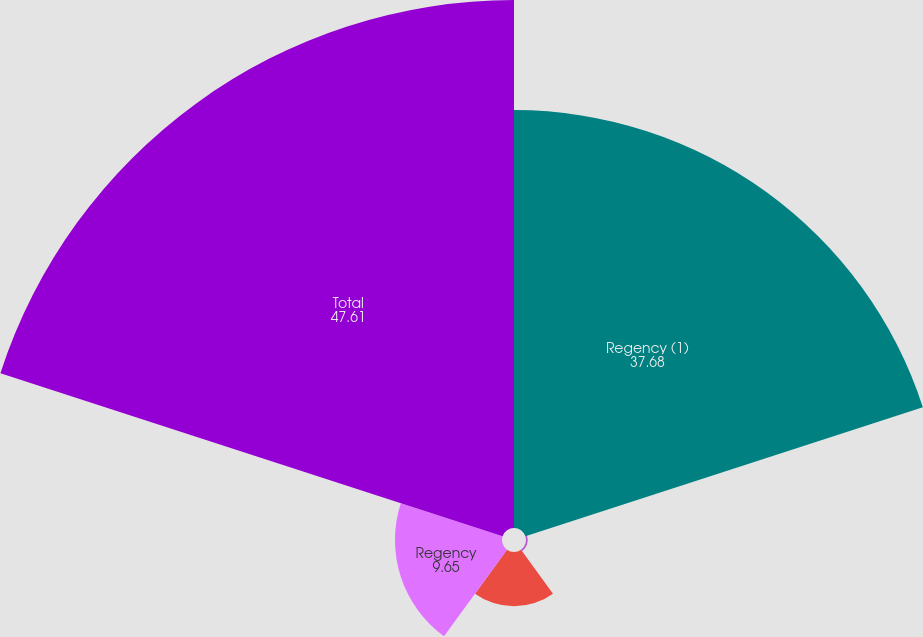Convert chart. <chart><loc_0><loc_0><loc_500><loc_500><pie_chart><fcel>Regency (1)<fcel>Regency's share of joint<fcel>Regency - office leases<fcel>Regency<fcel>Total<nl><fcel>37.68%<fcel>0.16%<fcel>4.9%<fcel>9.65%<fcel>47.61%<nl></chart> 